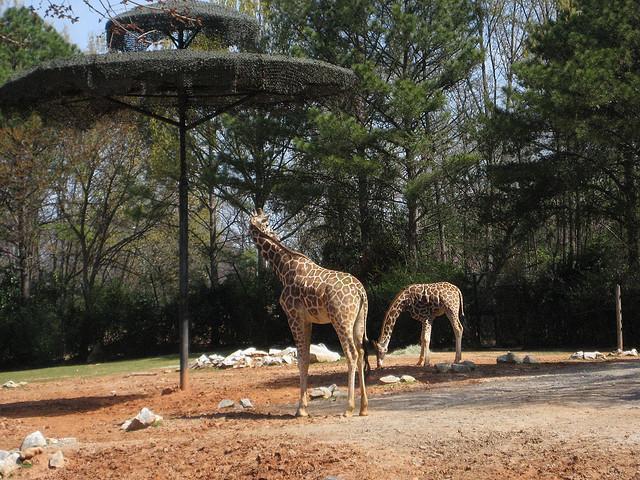What is the umbrella topped structure on the right supposed to resemble?
Select the accurate answer and provide justification: `Answer: choice
Rationale: srationale.`
Options: Traffic light, bush, lamp, tree. Answer: tree.
Rationale: The umbrella is covered in fake leaves. 